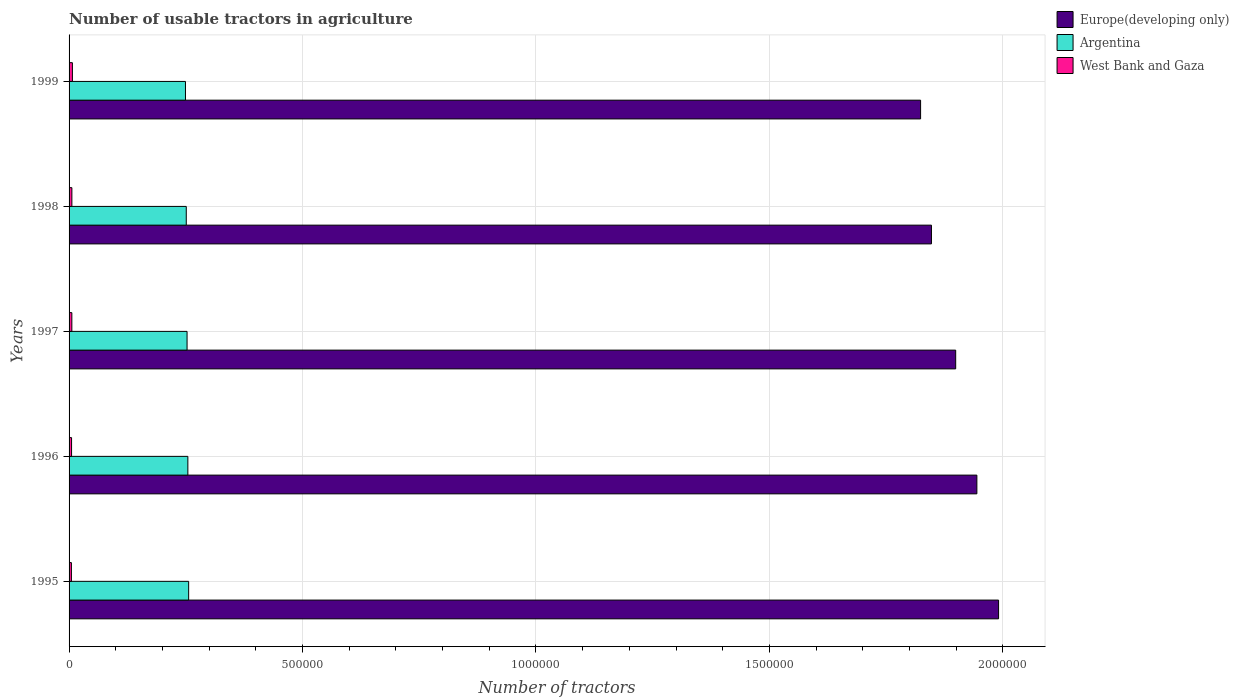Are the number of bars per tick equal to the number of legend labels?
Your answer should be very brief. Yes. Are the number of bars on each tick of the Y-axis equal?
Give a very brief answer. Yes. How many bars are there on the 3rd tick from the bottom?
Ensure brevity in your answer.  3. In how many cases, is the number of bars for a given year not equal to the number of legend labels?
Your response must be concise. 0. What is the number of usable tractors in agriculture in Europe(developing only) in 1996?
Keep it short and to the point. 1.94e+06. Across all years, what is the maximum number of usable tractors in agriculture in Europe(developing only)?
Provide a succinct answer. 1.99e+06. Across all years, what is the minimum number of usable tractors in agriculture in Europe(developing only)?
Provide a succinct answer. 1.82e+06. What is the total number of usable tractors in agriculture in Europe(developing only) in the graph?
Provide a short and direct response. 9.50e+06. What is the difference between the number of usable tractors in agriculture in Argentina in 1995 and that in 1999?
Your response must be concise. 6800. What is the difference between the number of usable tractors in agriculture in Argentina in 1996 and the number of usable tractors in agriculture in West Bank and Gaza in 1998?
Offer a very short reply. 2.48e+05. What is the average number of usable tractors in agriculture in West Bank and Gaza per year?
Offer a very short reply. 5886.6. In the year 1996, what is the difference between the number of usable tractors in agriculture in West Bank and Gaza and number of usable tractors in agriculture in Europe(developing only)?
Your response must be concise. -1.94e+06. What is the ratio of the number of usable tractors in agriculture in Argentina in 1997 to that in 1999?
Your answer should be compact. 1.01. Is the difference between the number of usable tractors in agriculture in West Bank and Gaza in 1996 and 1999 greater than the difference between the number of usable tractors in agriculture in Europe(developing only) in 1996 and 1999?
Give a very brief answer. No. What is the difference between the highest and the second highest number of usable tractors in agriculture in West Bank and Gaza?
Your response must be concise. 1116. What is the difference between the highest and the lowest number of usable tractors in agriculture in Europe(developing only)?
Offer a very short reply. 1.67e+05. What does the 2nd bar from the top in 1996 represents?
Your answer should be compact. Argentina. What does the 2nd bar from the bottom in 1999 represents?
Your answer should be very brief. Argentina. How many bars are there?
Your answer should be very brief. 15. Are all the bars in the graph horizontal?
Offer a terse response. Yes. How many years are there in the graph?
Give a very brief answer. 5. Are the values on the major ticks of X-axis written in scientific E-notation?
Offer a very short reply. No. How many legend labels are there?
Offer a very short reply. 3. What is the title of the graph?
Your answer should be compact. Number of usable tractors in agriculture. Does "Vanuatu" appear as one of the legend labels in the graph?
Ensure brevity in your answer.  No. What is the label or title of the X-axis?
Keep it short and to the point. Number of tractors. What is the label or title of the Y-axis?
Provide a succinct answer. Years. What is the Number of tractors of Europe(developing only) in 1995?
Provide a succinct answer. 1.99e+06. What is the Number of tractors in Argentina in 1995?
Make the answer very short. 2.56e+05. What is the Number of tractors of West Bank and Gaza in 1995?
Offer a terse response. 5012. What is the Number of tractors in Europe(developing only) in 1996?
Your answer should be compact. 1.94e+06. What is the Number of tractors of Argentina in 1996?
Offer a terse response. 2.54e+05. What is the Number of tractors of West Bank and Gaza in 1996?
Ensure brevity in your answer.  5348. What is the Number of tractors in Europe(developing only) in 1997?
Ensure brevity in your answer.  1.90e+06. What is the Number of tractors of Argentina in 1997?
Offer a very short reply. 2.53e+05. What is the Number of tractors of West Bank and Gaza in 1997?
Make the answer very short. 5927. What is the Number of tractors in Europe(developing only) in 1998?
Provide a succinct answer. 1.85e+06. What is the Number of tractors of Argentina in 1998?
Your response must be concise. 2.51e+05. What is the Number of tractors in West Bank and Gaza in 1998?
Provide a short and direct response. 6015. What is the Number of tractors in Europe(developing only) in 1999?
Your answer should be very brief. 1.82e+06. What is the Number of tractors in Argentina in 1999?
Your answer should be very brief. 2.49e+05. What is the Number of tractors in West Bank and Gaza in 1999?
Offer a terse response. 7131. Across all years, what is the maximum Number of tractors in Europe(developing only)?
Provide a short and direct response. 1.99e+06. Across all years, what is the maximum Number of tractors of Argentina?
Your answer should be compact. 2.56e+05. Across all years, what is the maximum Number of tractors in West Bank and Gaza?
Keep it short and to the point. 7131. Across all years, what is the minimum Number of tractors of Europe(developing only)?
Your response must be concise. 1.82e+06. Across all years, what is the minimum Number of tractors in Argentina?
Keep it short and to the point. 2.49e+05. Across all years, what is the minimum Number of tractors of West Bank and Gaza?
Your answer should be compact. 5012. What is the total Number of tractors in Europe(developing only) in the graph?
Your response must be concise. 9.50e+06. What is the total Number of tractors of Argentina in the graph?
Provide a short and direct response. 1.26e+06. What is the total Number of tractors of West Bank and Gaza in the graph?
Your answer should be very brief. 2.94e+04. What is the difference between the Number of tractors in Europe(developing only) in 1995 and that in 1996?
Keep it short and to the point. 4.65e+04. What is the difference between the Number of tractors of Argentina in 1995 and that in 1996?
Give a very brief answer. 1700. What is the difference between the Number of tractors in West Bank and Gaza in 1995 and that in 1996?
Your response must be concise. -336. What is the difference between the Number of tractors in Europe(developing only) in 1995 and that in 1997?
Offer a very short reply. 9.19e+04. What is the difference between the Number of tractors of Argentina in 1995 and that in 1997?
Your answer should be compact. 3400. What is the difference between the Number of tractors in West Bank and Gaza in 1995 and that in 1997?
Your answer should be very brief. -915. What is the difference between the Number of tractors of Europe(developing only) in 1995 and that in 1998?
Provide a short and direct response. 1.44e+05. What is the difference between the Number of tractors of Argentina in 1995 and that in 1998?
Offer a terse response. 5100. What is the difference between the Number of tractors of West Bank and Gaza in 1995 and that in 1998?
Offer a very short reply. -1003. What is the difference between the Number of tractors in Europe(developing only) in 1995 and that in 1999?
Give a very brief answer. 1.67e+05. What is the difference between the Number of tractors in Argentina in 1995 and that in 1999?
Make the answer very short. 6800. What is the difference between the Number of tractors in West Bank and Gaza in 1995 and that in 1999?
Your response must be concise. -2119. What is the difference between the Number of tractors in Europe(developing only) in 1996 and that in 1997?
Your answer should be very brief. 4.54e+04. What is the difference between the Number of tractors of Argentina in 1996 and that in 1997?
Provide a succinct answer. 1700. What is the difference between the Number of tractors of West Bank and Gaza in 1996 and that in 1997?
Ensure brevity in your answer.  -579. What is the difference between the Number of tractors of Europe(developing only) in 1996 and that in 1998?
Provide a succinct answer. 9.73e+04. What is the difference between the Number of tractors of Argentina in 1996 and that in 1998?
Ensure brevity in your answer.  3400. What is the difference between the Number of tractors in West Bank and Gaza in 1996 and that in 1998?
Provide a succinct answer. -667. What is the difference between the Number of tractors of Europe(developing only) in 1996 and that in 1999?
Your answer should be compact. 1.21e+05. What is the difference between the Number of tractors of Argentina in 1996 and that in 1999?
Offer a terse response. 5100. What is the difference between the Number of tractors in West Bank and Gaza in 1996 and that in 1999?
Ensure brevity in your answer.  -1783. What is the difference between the Number of tractors in Europe(developing only) in 1997 and that in 1998?
Offer a terse response. 5.19e+04. What is the difference between the Number of tractors in Argentina in 1997 and that in 1998?
Ensure brevity in your answer.  1700. What is the difference between the Number of tractors of West Bank and Gaza in 1997 and that in 1998?
Keep it short and to the point. -88. What is the difference between the Number of tractors of Europe(developing only) in 1997 and that in 1999?
Your response must be concise. 7.52e+04. What is the difference between the Number of tractors in Argentina in 1997 and that in 1999?
Ensure brevity in your answer.  3400. What is the difference between the Number of tractors of West Bank and Gaza in 1997 and that in 1999?
Your answer should be very brief. -1204. What is the difference between the Number of tractors of Europe(developing only) in 1998 and that in 1999?
Your answer should be compact. 2.33e+04. What is the difference between the Number of tractors in Argentina in 1998 and that in 1999?
Offer a terse response. 1700. What is the difference between the Number of tractors in West Bank and Gaza in 1998 and that in 1999?
Your answer should be compact. -1116. What is the difference between the Number of tractors of Europe(developing only) in 1995 and the Number of tractors of Argentina in 1996?
Your response must be concise. 1.74e+06. What is the difference between the Number of tractors in Europe(developing only) in 1995 and the Number of tractors in West Bank and Gaza in 1996?
Ensure brevity in your answer.  1.99e+06. What is the difference between the Number of tractors in Argentina in 1995 and the Number of tractors in West Bank and Gaza in 1996?
Ensure brevity in your answer.  2.51e+05. What is the difference between the Number of tractors of Europe(developing only) in 1995 and the Number of tractors of Argentina in 1997?
Give a very brief answer. 1.74e+06. What is the difference between the Number of tractors of Europe(developing only) in 1995 and the Number of tractors of West Bank and Gaza in 1997?
Provide a succinct answer. 1.98e+06. What is the difference between the Number of tractors of Argentina in 1995 and the Number of tractors of West Bank and Gaza in 1997?
Provide a succinct answer. 2.50e+05. What is the difference between the Number of tractors of Europe(developing only) in 1995 and the Number of tractors of Argentina in 1998?
Give a very brief answer. 1.74e+06. What is the difference between the Number of tractors of Europe(developing only) in 1995 and the Number of tractors of West Bank and Gaza in 1998?
Give a very brief answer. 1.98e+06. What is the difference between the Number of tractors of Argentina in 1995 and the Number of tractors of West Bank and Gaza in 1998?
Make the answer very short. 2.50e+05. What is the difference between the Number of tractors of Europe(developing only) in 1995 and the Number of tractors of Argentina in 1999?
Your answer should be very brief. 1.74e+06. What is the difference between the Number of tractors of Europe(developing only) in 1995 and the Number of tractors of West Bank and Gaza in 1999?
Provide a succinct answer. 1.98e+06. What is the difference between the Number of tractors in Argentina in 1995 and the Number of tractors in West Bank and Gaza in 1999?
Keep it short and to the point. 2.49e+05. What is the difference between the Number of tractors in Europe(developing only) in 1996 and the Number of tractors in Argentina in 1997?
Offer a terse response. 1.69e+06. What is the difference between the Number of tractors of Europe(developing only) in 1996 and the Number of tractors of West Bank and Gaza in 1997?
Ensure brevity in your answer.  1.94e+06. What is the difference between the Number of tractors of Argentina in 1996 and the Number of tractors of West Bank and Gaza in 1997?
Give a very brief answer. 2.48e+05. What is the difference between the Number of tractors of Europe(developing only) in 1996 and the Number of tractors of Argentina in 1998?
Provide a succinct answer. 1.69e+06. What is the difference between the Number of tractors in Europe(developing only) in 1996 and the Number of tractors in West Bank and Gaza in 1998?
Offer a terse response. 1.94e+06. What is the difference between the Number of tractors in Argentina in 1996 and the Number of tractors in West Bank and Gaza in 1998?
Your response must be concise. 2.48e+05. What is the difference between the Number of tractors in Europe(developing only) in 1996 and the Number of tractors in Argentina in 1999?
Ensure brevity in your answer.  1.69e+06. What is the difference between the Number of tractors of Europe(developing only) in 1996 and the Number of tractors of West Bank and Gaza in 1999?
Give a very brief answer. 1.94e+06. What is the difference between the Number of tractors of Argentina in 1996 and the Number of tractors of West Bank and Gaza in 1999?
Ensure brevity in your answer.  2.47e+05. What is the difference between the Number of tractors in Europe(developing only) in 1997 and the Number of tractors in Argentina in 1998?
Offer a terse response. 1.65e+06. What is the difference between the Number of tractors of Europe(developing only) in 1997 and the Number of tractors of West Bank and Gaza in 1998?
Offer a very short reply. 1.89e+06. What is the difference between the Number of tractors of Argentina in 1997 and the Number of tractors of West Bank and Gaza in 1998?
Offer a terse response. 2.47e+05. What is the difference between the Number of tractors in Europe(developing only) in 1997 and the Number of tractors in Argentina in 1999?
Offer a very short reply. 1.65e+06. What is the difference between the Number of tractors of Europe(developing only) in 1997 and the Number of tractors of West Bank and Gaza in 1999?
Your answer should be compact. 1.89e+06. What is the difference between the Number of tractors of Argentina in 1997 and the Number of tractors of West Bank and Gaza in 1999?
Provide a succinct answer. 2.46e+05. What is the difference between the Number of tractors in Europe(developing only) in 1998 and the Number of tractors in Argentina in 1999?
Ensure brevity in your answer.  1.60e+06. What is the difference between the Number of tractors in Europe(developing only) in 1998 and the Number of tractors in West Bank and Gaza in 1999?
Keep it short and to the point. 1.84e+06. What is the difference between the Number of tractors of Argentina in 1998 and the Number of tractors of West Bank and Gaza in 1999?
Your answer should be compact. 2.44e+05. What is the average Number of tractors of Europe(developing only) per year?
Offer a very short reply. 1.90e+06. What is the average Number of tractors in Argentina per year?
Provide a succinct answer. 2.53e+05. What is the average Number of tractors in West Bank and Gaza per year?
Your response must be concise. 5886.6. In the year 1995, what is the difference between the Number of tractors of Europe(developing only) and Number of tractors of Argentina?
Your response must be concise. 1.73e+06. In the year 1995, what is the difference between the Number of tractors in Europe(developing only) and Number of tractors in West Bank and Gaza?
Provide a short and direct response. 1.99e+06. In the year 1995, what is the difference between the Number of tractors of Argentina and Number of tractors of West Bank and Gaza?
Ensure brevity in your answer.  2.51e+05. In the year 1996, what is the difference between the Number of tractors of Europe(developing only) and Number of tractors of Argentina?
Keep it short and to the point. 1.69e+06. In the year 1996, what is the difference between the Number of tractors of Europe(developing only) and Number of tractors of West Bank and Gaza?
Keep it short and to the point. 1.94e+06. In the year 1996, what is the difference between the Number of tractors in Argentina and Number of tractors in West Bank and Gaza?
Make the answer very short. 2.49e+05. In the year 1997, what is the difference between the Number of tractors of Europe(developing only) and Number of tractors of Argentina?
Provide a succinct answer. 1.65e+06. In the year 1997, what is the difference between the Number of tractors in Europe(developing only) and Number of tractors in West Bank and Gaza?
Make the answer very short. 1.89e+06. In the year 1997, what is the difference between the Number of tractors of Argentina and Number of tractors of West Bank and Gaza?
Make the answer very short. 2.47e+05. In the year 1998, what is the difference between the Number of tractors in Europe(developing only) and Number of tractors in Argentina?
Keep it short and to the point. 1.60e+06. In the year 1998, what is the difference between the Number of tractors of Europe(developing only) and Number of tractors of West Bank and Gaza?
Your response must be concise. 1.84e+06. In the year 1998, what is the difference between the Number of tractors of Argentina and Number of tractors of West Bank and Gaza?
Your answer should be very brief. 2.45e+05. In the year 1999, what is the difference between the Number of tractors of Europe(developing only) and Number of tractors of Argentina?
Your answer should be very brief. 1.57e+06. In the year 1999, what is the difference between the Number of tractors in Europe(developing only) and Number of tractors in West Bank and Gaza?
Keep it short and to the point. 1.82e+06. In the year 1999, what is the difference between the Number of tractors in Argentina and Number of tractors in West Bank and Gaza?
Keep it short and to the point. 2.42e+05. What is the ratio of the Number of tractors in Europe(developing only) in 1995 to that in 1996?
Give a very brief answer. 1.02. What is the ratio of the Number of tractors of West Bank and Gaza in 1995 to that in 1996?
Provide a succinct answer. 0.94. What is the ratio of the Number of tractors in Europe(developing only) in 1995 to that in 1997?
Make the answer very short. 1.05. What is the ratio of the Number of tractors of Argentina in 1995 to that in 1997?
Your response must be concise. 1.01. What is the ratio of the Number of tractors in West Bank and Gaza in 1995 to that in 1997?
Give a very brief answer. 0.85. What is the ratio of the Number of tractors of Europe(developing only) in 1995 to that in 1998?
Keep it short and to the point. 1.08. What is the ratio of the Number of tractors in Argentina in 1995 to that in 1998?
Ensure brevity in your answer.  1.02. What is the ratio of the Number of tractors in Europe(developing only) in 1995 to that in 1999?
Offer a terse response. 1.09. What is the ratio of the Number of tractors of Argentina in 1995 to that in 1999?
Provide a succinct answer. 1.03. What is the ratio of the Number of tractors of West Bank and Gaza in 1995 to that in 1999?
Your answer should be very brief. 0.7. What is the ratio of the Number of tractors in Europe(developing only) in 1996 to that in 1997?
Keep it short and to the point. 1.02. What is the ratio of the Number of tractors in Argentina in 1996 to that in 1997?
Provide a short and direct response. 1.01. What is the ratio of the Number of tractors of West Bank and Gaza in 1996 to that in 1997?
Give a very brief answer. 0.9. What is the ratio of the Number of tractors of Europe(developing only) in 1996 to that in 1998?
Ensure brevity in your answer.  1.05. What is the ratio of the Number of tractors of Argentina in 1996 to that in 1998?
Provide a succinct answer. 1.01. What is the ratio of the Number of tractors of West Bank and Gaza in 1996 to that in 1998?
Provide a short and direct response. 0.89. What is the ratio of the Number of tractors of Europe(developing only) in 1996 to that in 1999?
Offer a very short reply. 1.07. What is the ratio of the Number of tractors of Argentina in 1996 to that in 1999?
Your response must be concise. 1.02. What is the ratio of the Number of tractors in Europe(developing only) in 1997 to that in 1998?
Offer a terse response. 1.03. What is the ratio of the Number of tractors in Argentina in 1997 to that in 1998?
Offer a terse response. 1.01. What is the ratio of the Number of tractors of West Bank and Gaza in 1997 to that in 1998?
Keep it short and to the point. 0.99. What is the ratio of the Number of tractors in Europe(developing only) in 1997 to that in 1999?
Provide a succinct answer. 1.04. What is the ratio of the Number of tractors of Argentina in 1997 to that in 1999?
Ensure brevity in your answer.  1.01. What is the ratio of the Number of tractors in West Bank and Gaza in 1997 to that in 1999?
Your answer should be compact. 0.83. What is the ratio of the Number of tractors in Europe(developing only) in 1998 to that in 1999?
Provide a succinct answer. 1.01. What is the ratio of the Number of tractors in Argentina in 1998 to that in 1999?
Your answer should be compact. 1.01. What is the ratio of the Number of tractors of West Bank and Gaza in 1998 to that in 1999?
Offer a very short reply. 0.84. What is the difference between the highest and the second highest Number of tractors of Europe(developing only)?
Your answer should be very brief. 4.65e+04. What is the difference between the highest and the second highest Number of tractors of Argentina?
Your answer should be compact. 1700. What is the difference between the highest and the second highest Number of tractors of West Bank and Gaza?
Your response must be concise. 1116. What is the difference between the highest and the lowest Number of tractors in Europe(developing only)?
Your answer should be very brief. 1.67e+05. What is the difference between the highest and the lowest Number of tractors in Argentina?
Give a very brief answer. 6800. What is the difference between the highest and the lowest Number of tractors in West Bank and Gaza?
Your response must be concise. 2119. 